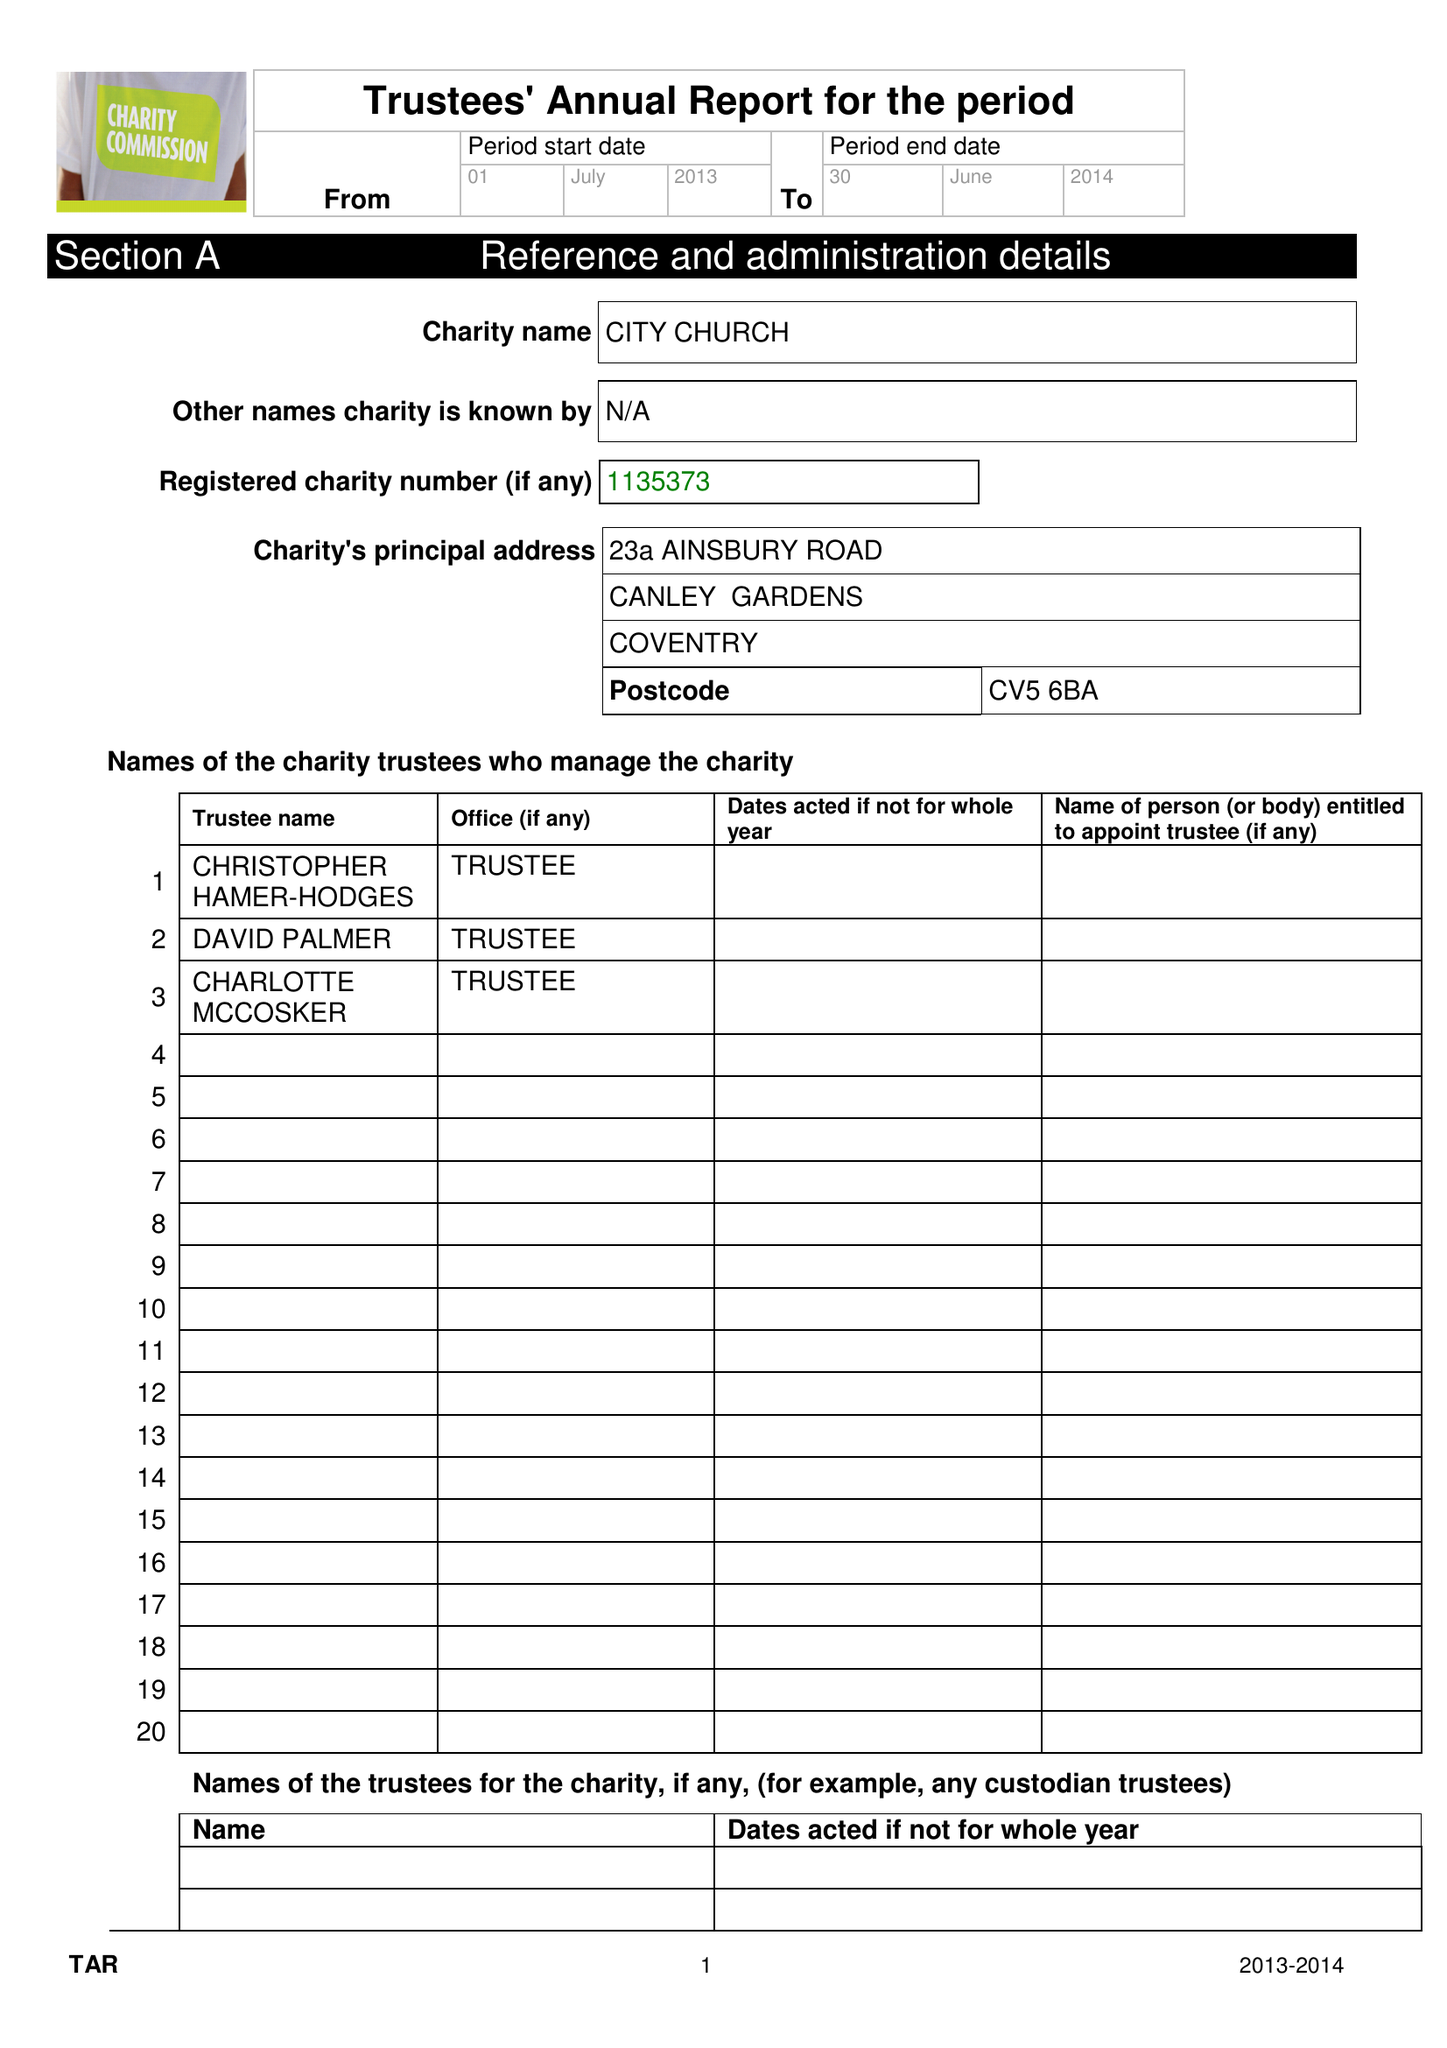What is the value for the address__street_line?
Answer the question using a single word or phrase. 23A AINSBURY ROAD 